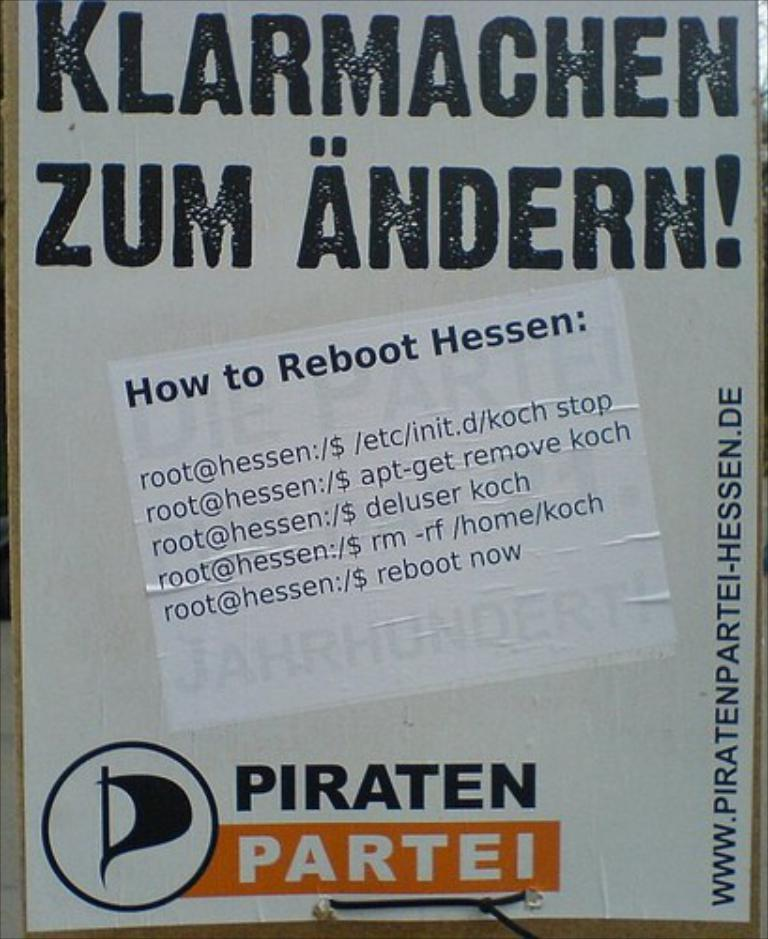<image>
Summarize the visual content of the image. Instructions and links for how to reboot Hessen. 